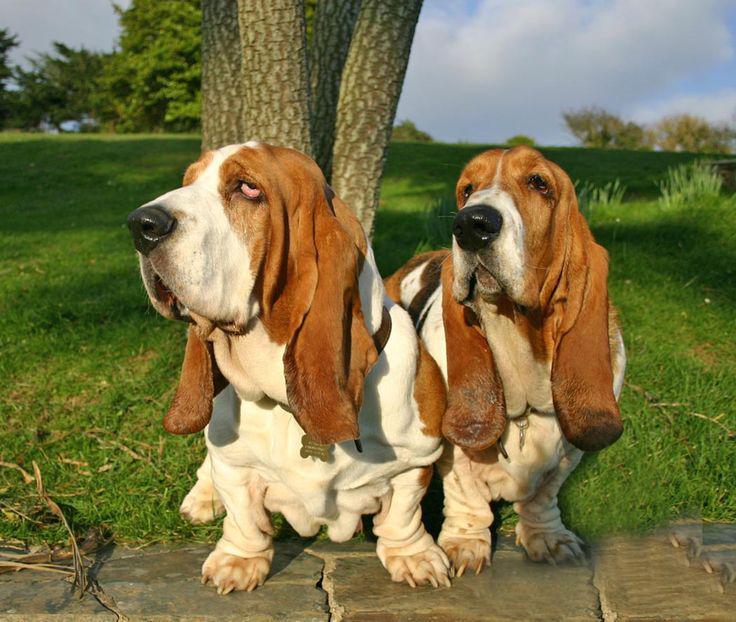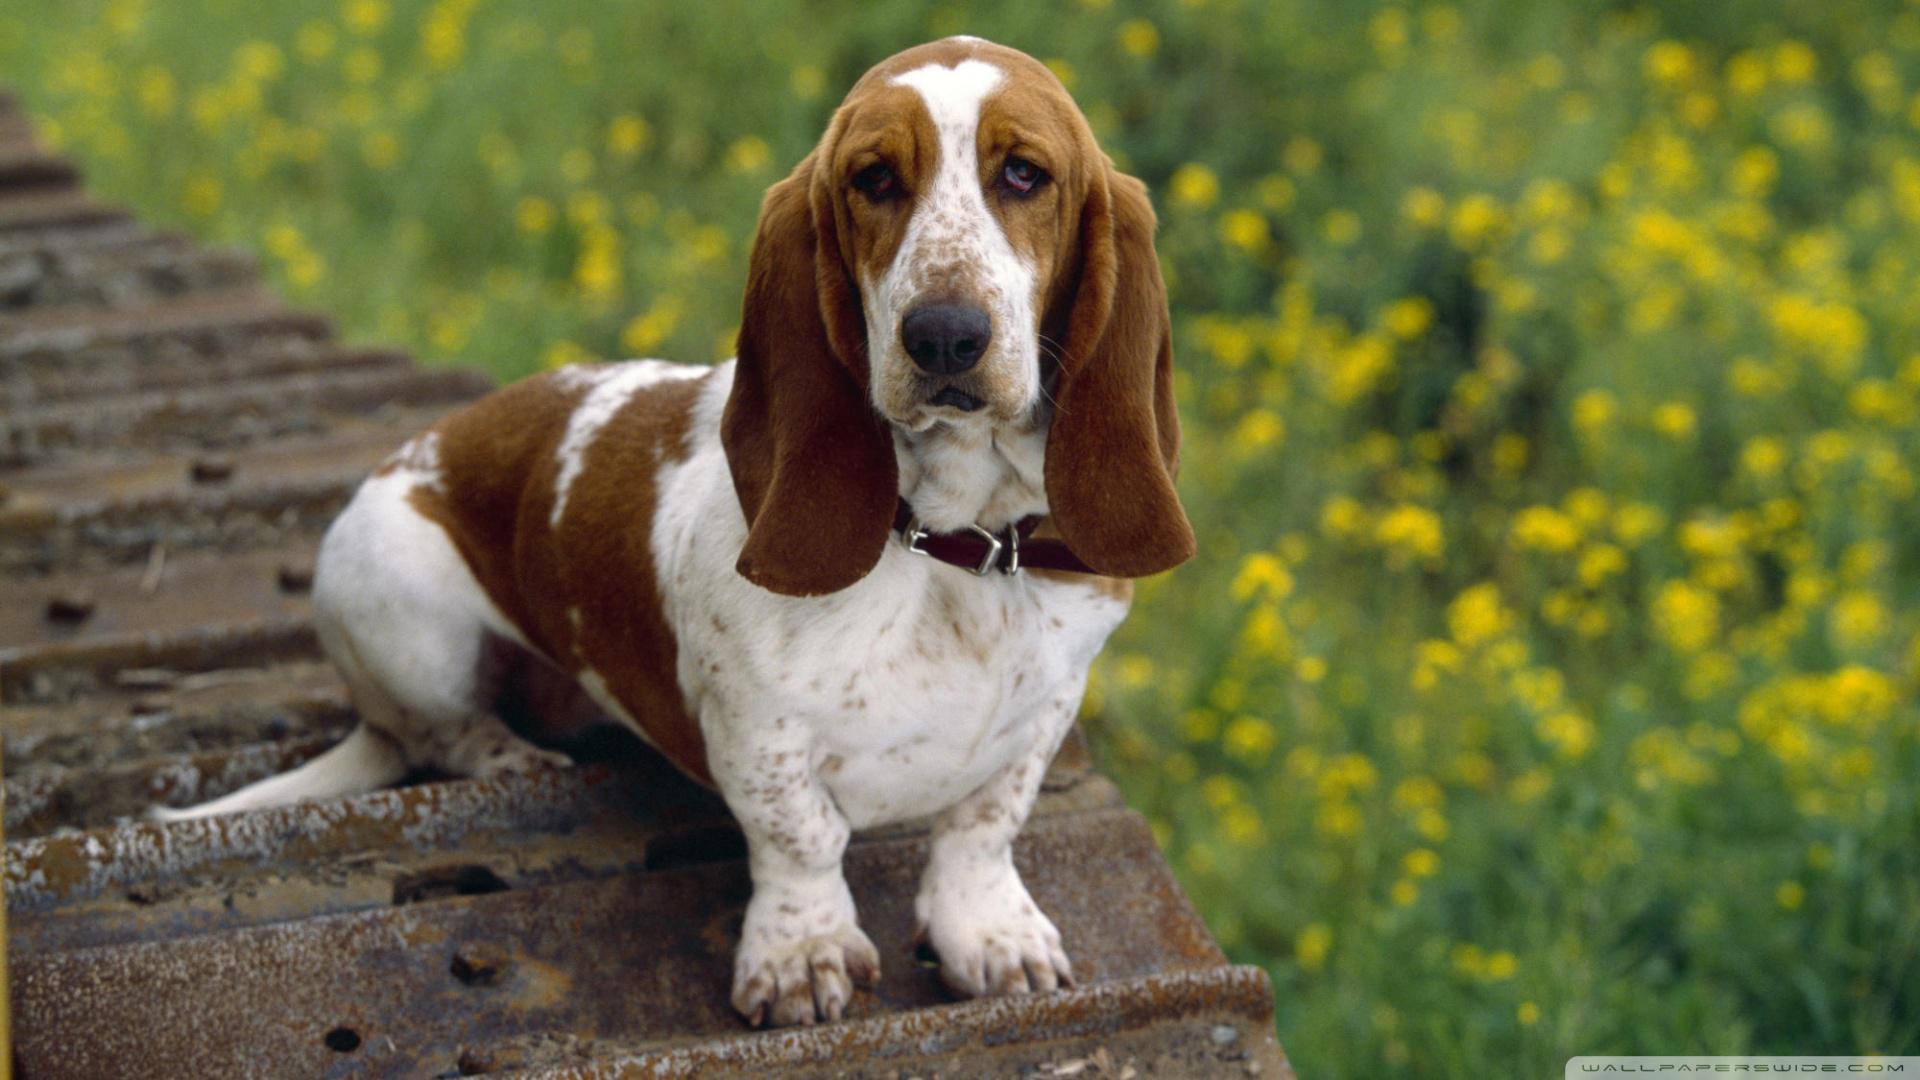The first image is the image on the left, the second image is the image on the right. Assess this claim about the two images: "There are three dogs". Correct or not? Answer yes or no. Yes. The first image is the image on the left, the second image is the image on the right. Given the left and right images, does the statement "Exactly three bassett hounds are pictured, two of them side by side." hold true? Answer yes or no. Yes. 